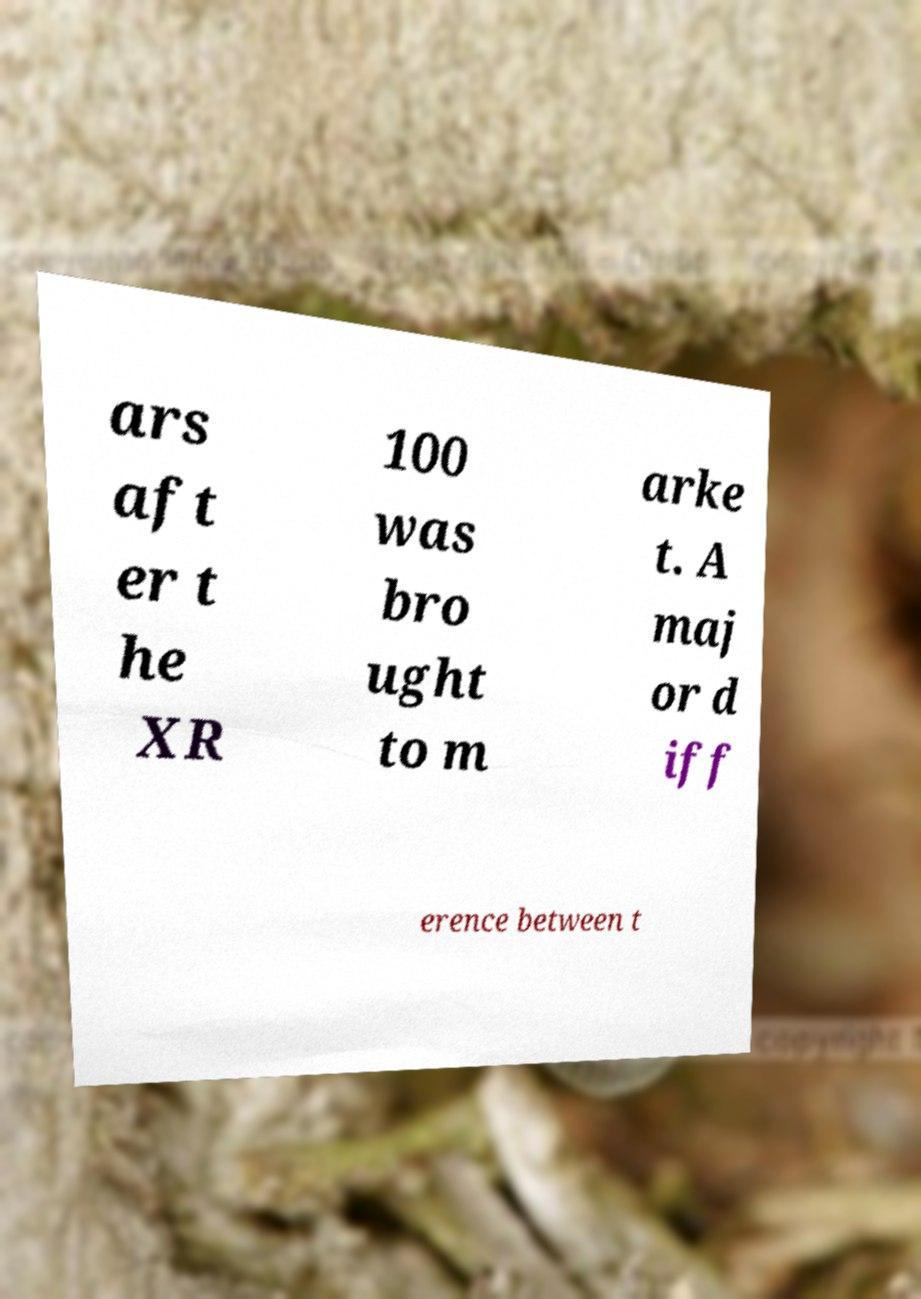For documentation purposes, I need the text within this image transcribed. Could you provide that? ars aft er t he XR 100 was bro ught to m arke t. A maj or d iff erence between t 